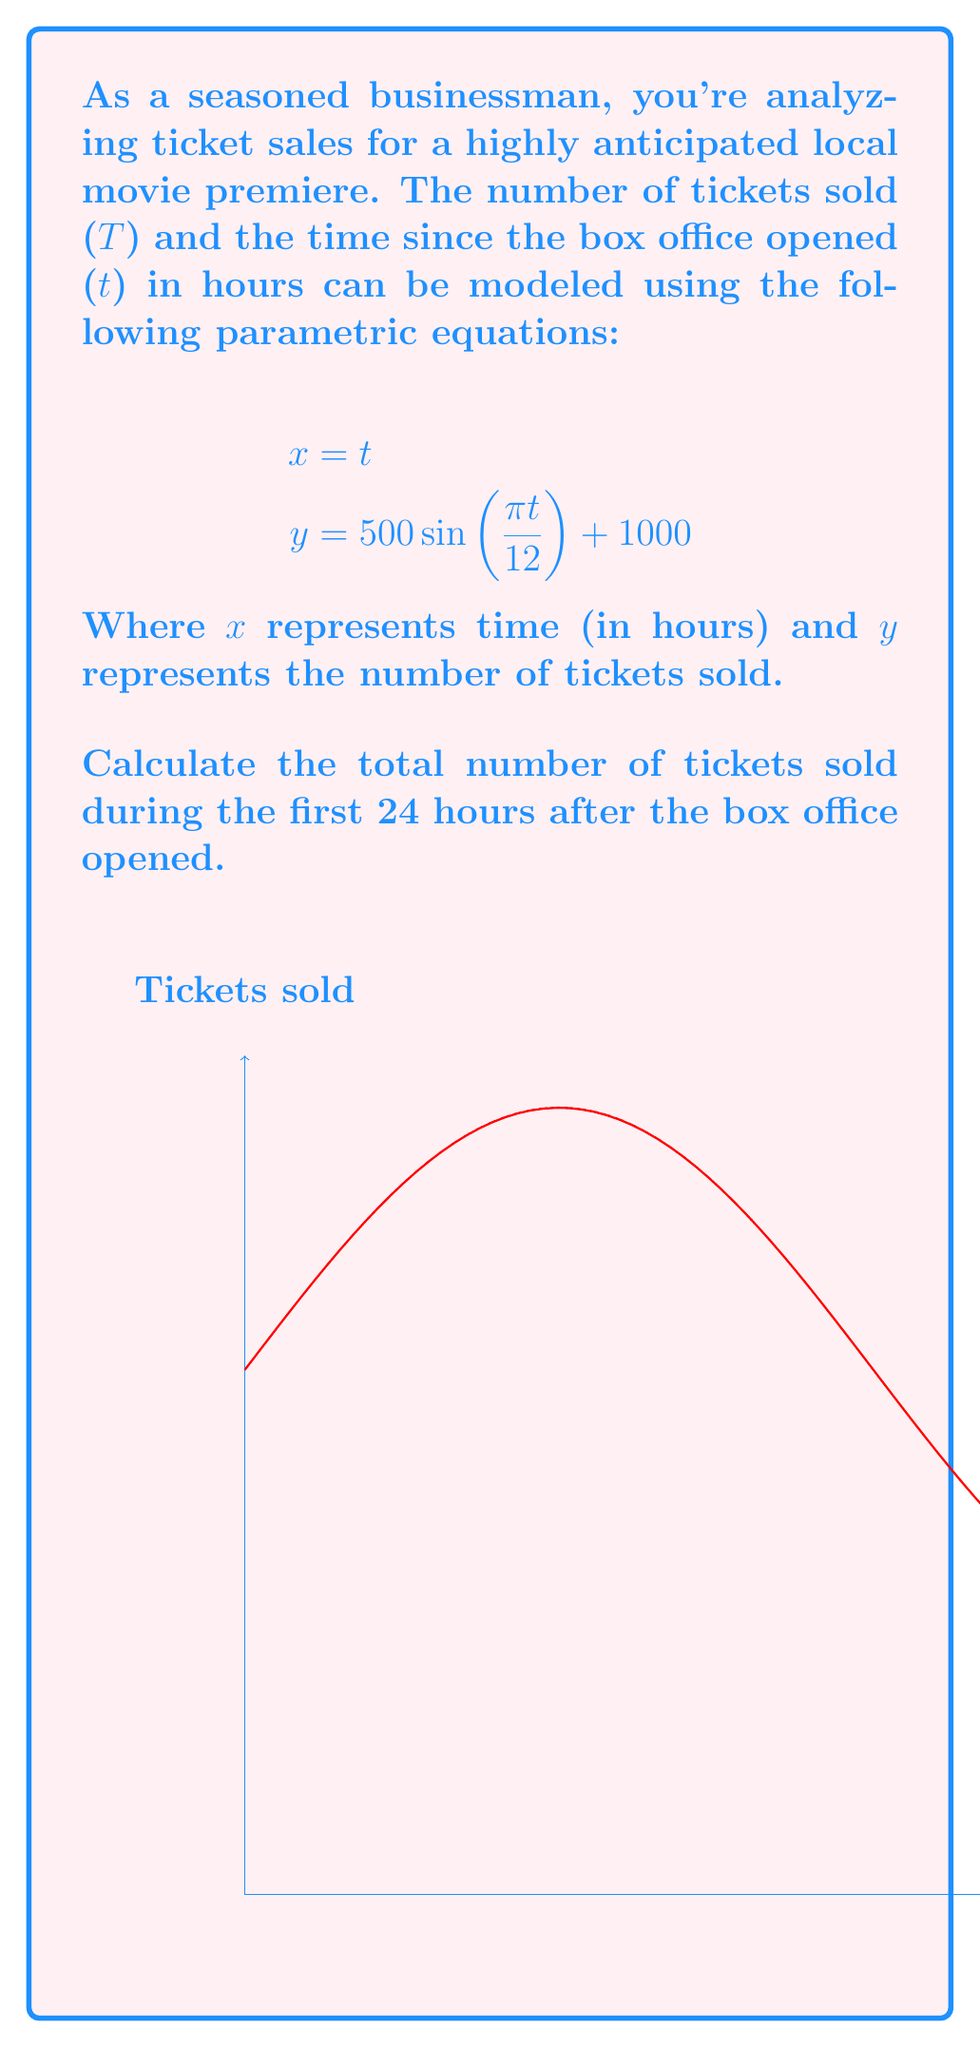Can you solve this math problem? To solve this problem, we need to follow these steps:

1) The parametric equations given are:
   $$x = t$$
   $$y = 500\sin(\frac{\pi t}{12}) + 1000$$

2) We need to find the area under this curve from t = 0 to t = 24.

3) In parametric form, the formula for the area under a curve is:
   $$A = \int_{a}^{b} y(t) \frac{dx}{dt} dt$$

4) In our case, $\frac{dx}{dt} = 1$ (since x = t), so our integral simplifies to:
   $$A = \int_{0}^{24} (500\sin(\frac{\pi t}{12}) + 1000) dt$$

5) Let's solve this integral:
   $$A = [-500 \cdot \frac{12}{\pi} \cos(\frac{\pi t}{12}) + 1000t]_{0}^{24}$$

6) Evaluating at the limits:
   $$A = [-500 \cdot \frac{12}{\pi} \cos(2\pi) + 1000 \cdot 24] - [-500 \cdot \frac{12}{\pi} \cos(0) + 1000 \cdot 0]$$

7) Simplify:
   $$A = [-500 \cdot \frac{12}{\pi} + 24000] - [-500 \cdot \frac{12}{\pi}]$$
   $$A = 24000$$

Therefore, the total number of tickets sold during the first 24 hours is 24,000.
Answer: 24,000 tickets 